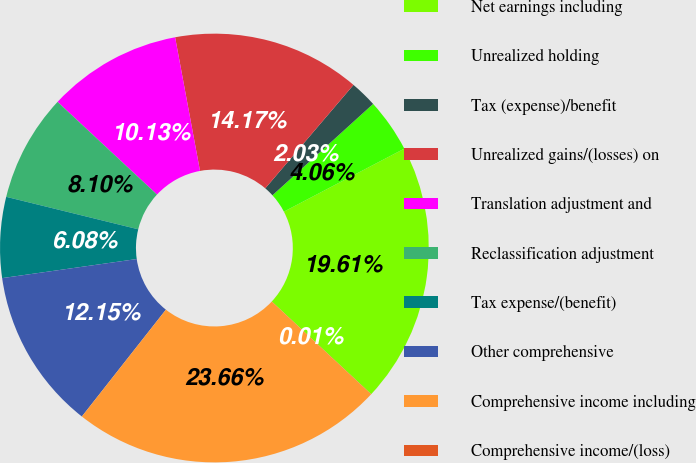Convert chart to OTSL. <chart><loc_0><loc_0><loc_500><loc_500><pie_chart><fcel>Net earnings including<fcel>Unrealized holding<fcel>Tax (expense)/benefit<fcel>Unrealized gains/(losses) on<fcel>Translation adjustment and<fcel>Reclassification adjustment<fcel>Tax expense/(benefit)<fcel>Other comprehensive<fcel>Comprehensive income including<fcel>Comprehensive income/(loss)<nl><fcel>19.61%<fcel>4.06%<fcel>2.03%<fcel>14.17%<fcel>10.13%<fcel>8.1%<fcel>6.08%<fcel>12.15%<fcel>23.66%<fcel>0.01%<nl></chart> 